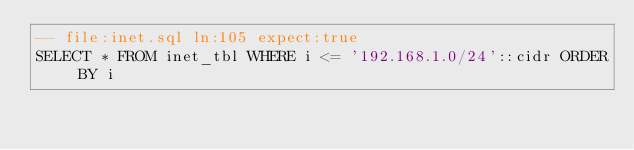Convert code to text. <code><loc_0><loc_0><loc_500><loc_500><_SQL_>-- file:inet.sql ln:105 expect:true
SELECT * FROM inet_tbl WHERE i <= '192.168.1.0/24'::cidr ORDER BY i
</code> 